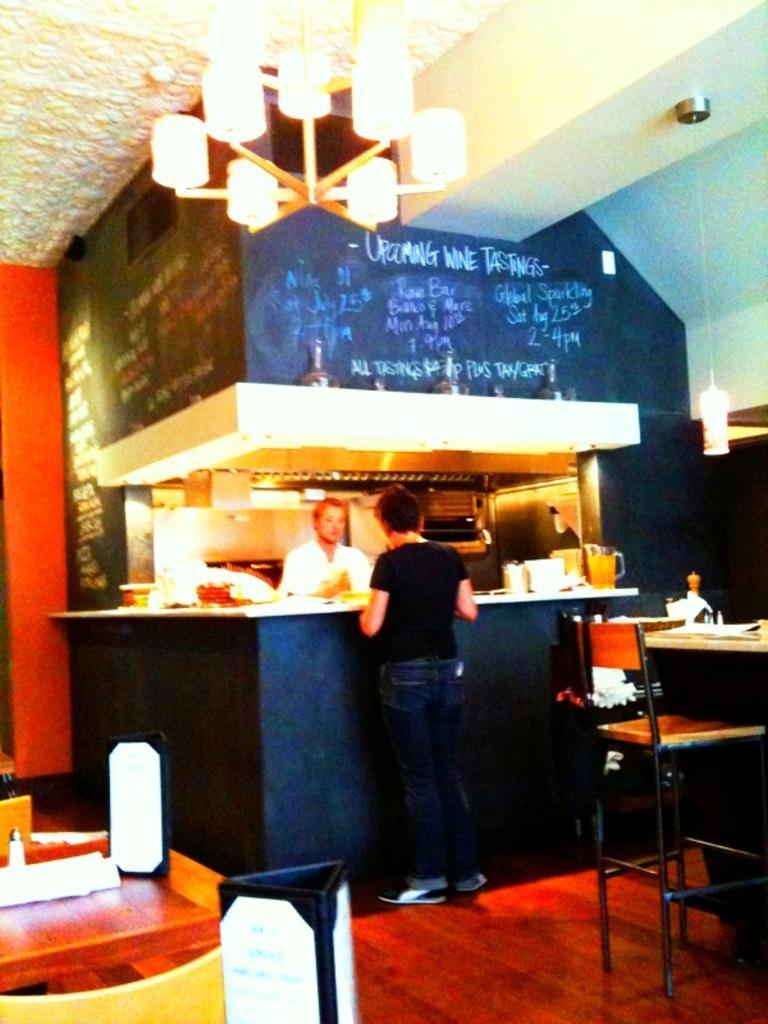Can you describe this image briefly? In the picture we can see two persons, one person is standing outside the table and one person is standing behind the table, in the picture we can also see some tables, chairs, lights to the ceiling and table, on the table we can see jugs with some drink, and the floor. 